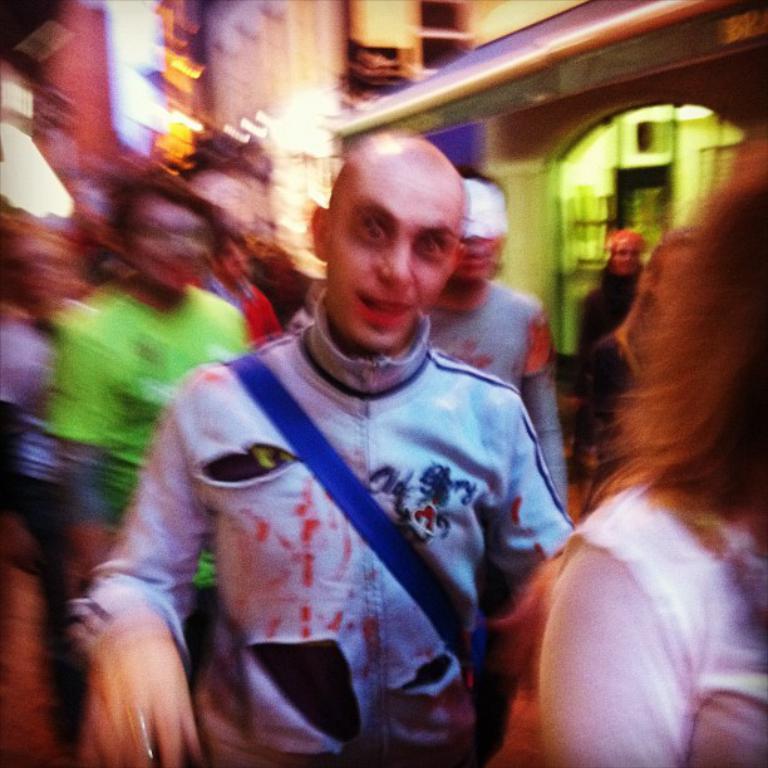Describe this image in one or two sentences. In this image I can see number of people are standing. In the background I can see few buildings and I can see this image is little bit blurry. 